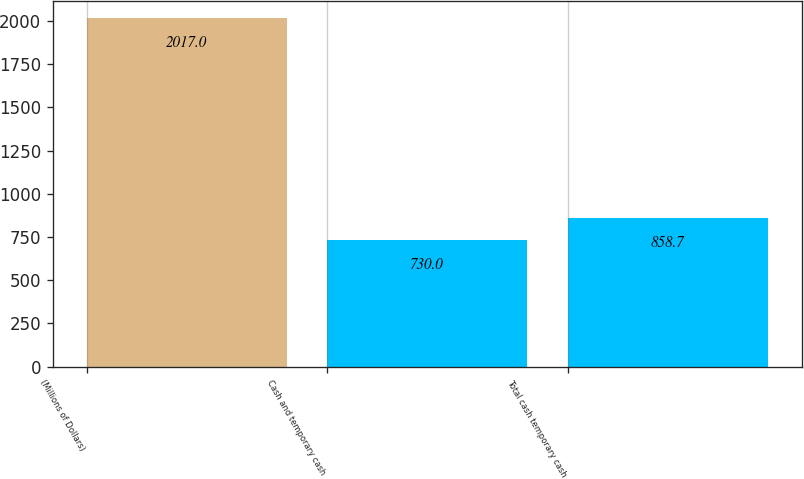<chart> <loc_0><loc_0><loc_500><loc_500><bar_chart><fcel>(Millions of Dollars)<fcel>Cash and temporary cash<fcel>Total cash temporary cash<nl><fcel>2017<fcel>730<fcel>858.7<nl></chart> 